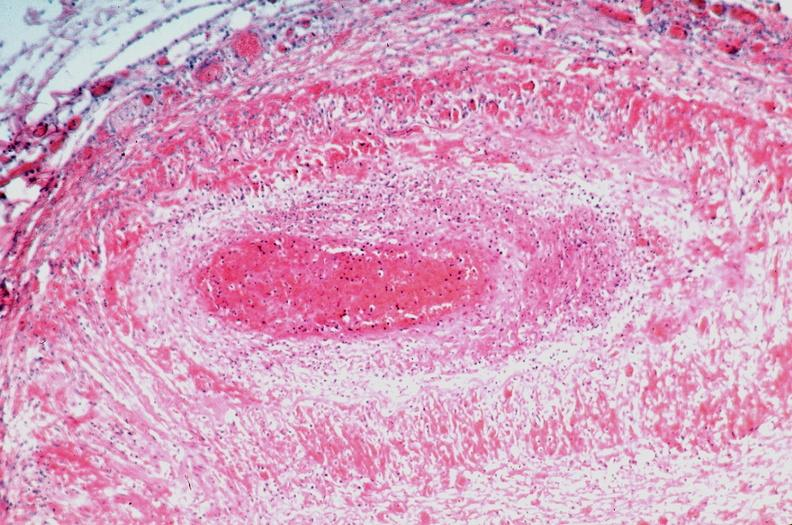what is present?
Answer the question using a single word or phrase. Cardiovascular 